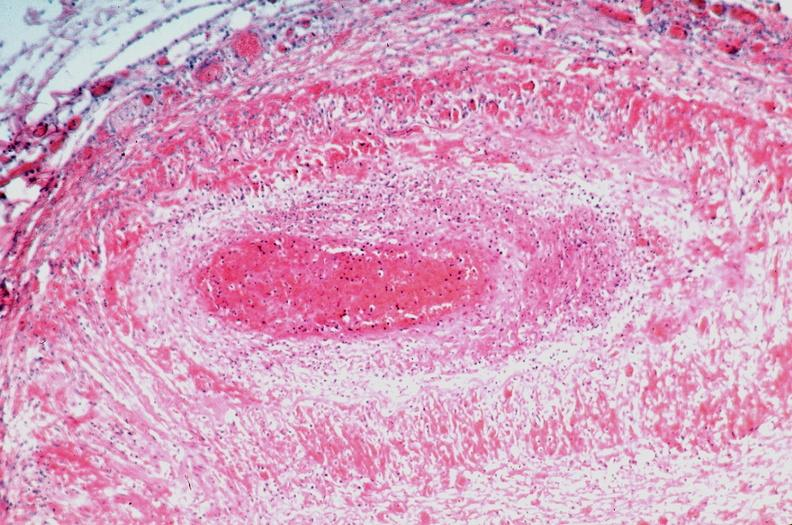what is present?
Answer the question using a single word or phrase. Cardiovascular 